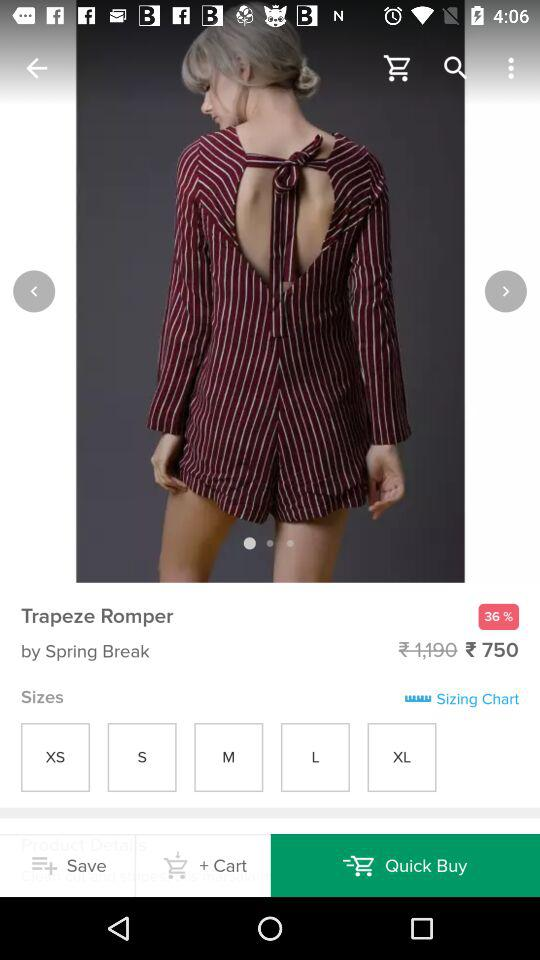What is the price? The price is ₹750. 